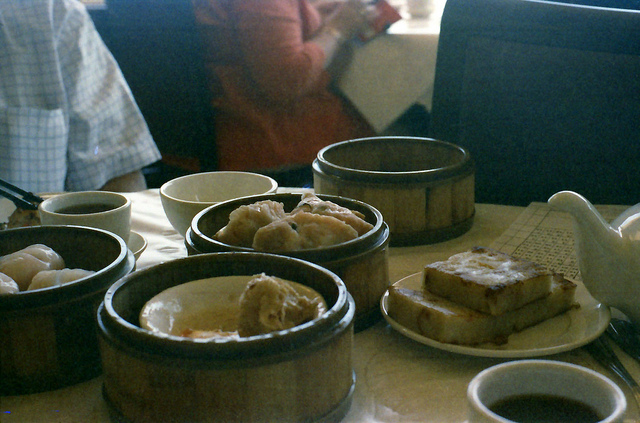<image>What type of meal is this? I am not sure about the type of meal. It could be dinner, dessert, dim sum, lunch, soup, tea, or breakfast. What type of meal is this? I don't know what type of meal this is. It can be dinner, dessert, dim sum, lunch, soup, tea, or breakfast. 